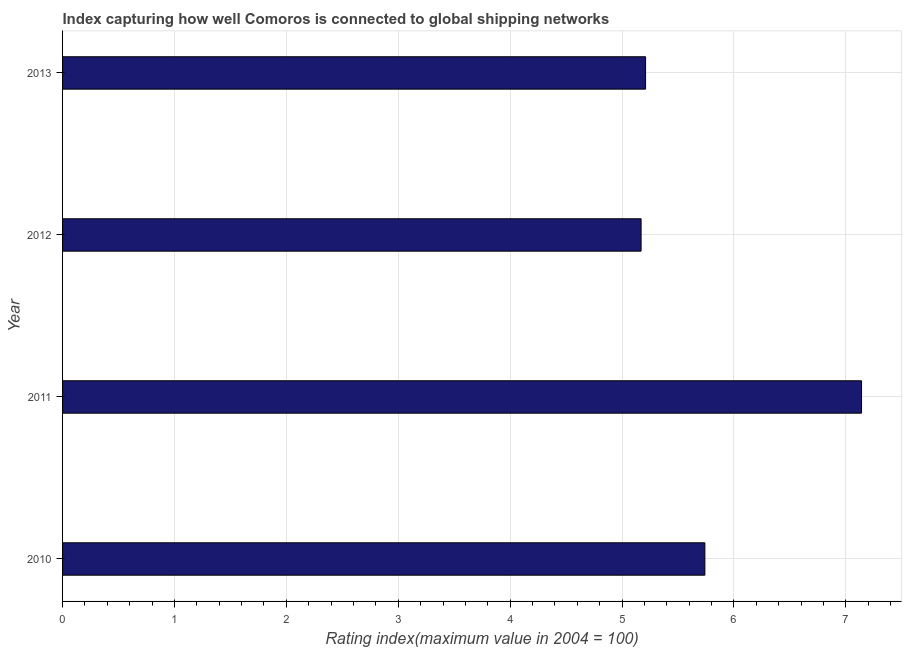Does the graph contain any zero values?
Your response must be concise. No. Does the graph contain grids?
Ensure brevity in your answer.  Yes. What is the title of the graph?
Keep it short and to the point. Index capturing how well Comoros is connected to global shipping networks. What is the label or title of the X-axis?
Keep it short and to the point. Rating index(maximum value in 2004 = 100). What is the label or title of the Y-axis?
Keep it short and to the point. Year. What is the liner shipping connectivity index in 2010?
Ensure brevity in your answer.  5.74. Across all years, what is the maximum liner shipping connectivity index?
Your response must be concise. 7.14. Across all years, what is the minimum liner shipping connectivity index?
Offer a terse response. 5.17. In which year was the liner shipping connectivity index maximum?
Ensure brevity in your answer.  2011. What is the sum of the liner shipping connectivity index?
Offer a terse response. 23.26. What is the difference between the liner shipping connectivity index in 2010 and 2013?
Provide a succinct answer. 0.53. What is the average liner shipping connectivity index per year?
Your response must be concise. 5.82. What is the median liner shipping connectivity index?
Your response must be concise. 5.47. Do a majority of the years between 2013 and 2012 (inclusive) have liner shipping connectivity index greater than 1.4 ?
Your answer should be compact. No. What is the ratio of the liner shipping connectivity index in 2011 to that in 2012?
Give a very brief answer. 1.38. What is the difference between the highest and the second highest liner shipping connectivity index?
Your answer should be compact. 1.4. What is the difference between the highest and the lowest liner shipping connectivity index?
Give a very brief answer. 1.97. How many bars are there?
Your response must be concise. 4. Are all the bars in the graph horizontal?
Your response must be concise. Yes. How many years are there in the graph?
Give a very brief answer. 4. What is the difference between two consecutive major ticks on the X-axis?
Offer a terse response. 1. Are the values on the major ticks of X-axis written in scientific E-notation?
Offer a very short reply. No. What is the Rating index(maximum value in 2004 = 100) in 2010?
Offer a terse response. 5.74. What is the Rating index(maximum value in 2004 = 100) of 2011?
Give a very brief answer. 7.14. What is the Rating index(maximum value in 2004 = 100) of 2012?
Ensure brevity in your answer.  5.17. What is the Rating index(maximum value in 2004 = 100) in 2013?
Provide a succinct answer. 5.21. What is the difference between the Rating index(maximum value in 2004 = 100) in 2010 and 2011?
Make the answer very short. -1.4. What is the difference between the Rating index(maximum value in 2004 = 100) in 2010 and 2012?
Your answer should be very brief. 0.57. What is the difference between the Rating index(maximum value in 2004 = 100) in 2010 and 2013?
Your response must be concise. 0.53. What is the difference between the Rating index(maximum value in 2004 = 100) in 2011 and 2012?
Offer a terse response. 1.97. What is the difference between the Rating index(maximum value in 2004 = 100) in 2011 and 2013?
Make the answer very short. 1.93. What is the difference between the Rating index(maximum value in 2004 = 100) in 2012 and 2013?
Give a very brief answer. -0.04. What is the ratio of the Rating index(maximum value in 2004 = 100) in 2010 to that in 2011?
Your response must be concise. 0.8. What is the ratio of the Rating index(maximum value in 2004 = 100) in 2010 to that in 2012?
Your answer should be very brief. 1.11. What is the ratio of the Rating index(maximum value in 2004 = 100) in 2010 to that in 2013?
Provide a short and direct response. 1.1. What is the ratio of the Rating index(maximum value in 2004 = 100) in 2011 to that in 2012?
Your answer should be very brief. 1.38. What is the ratio of the Rating index(maximum value in 2004 = 100) in 2011 to that in 2013?
Your response must be concise. 1.37. 